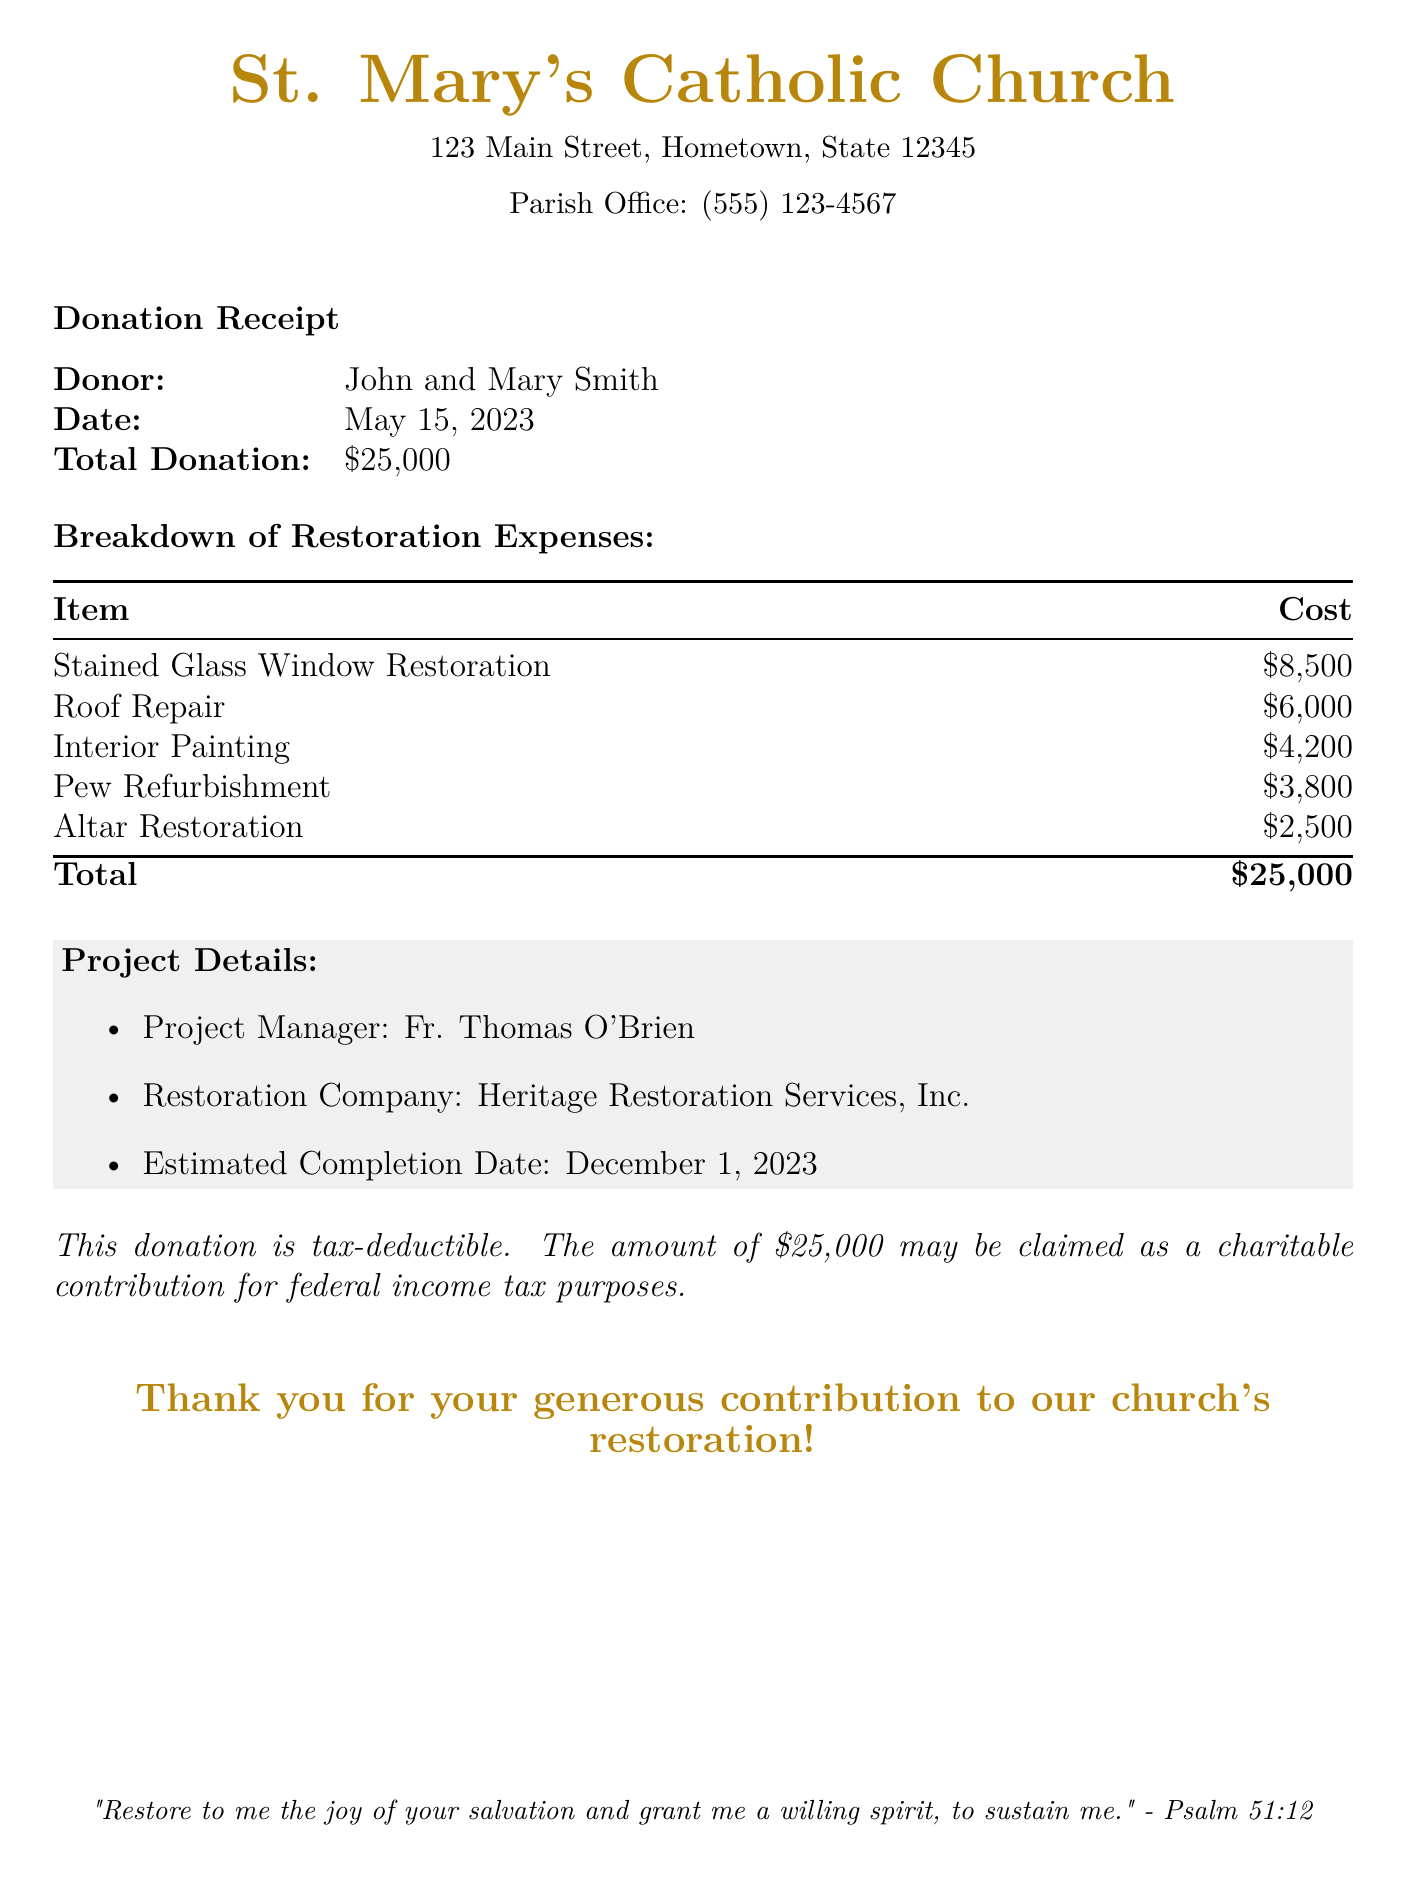what is the name of the church? The name of the church is provided at the top of the document.
Answer: St. Mary's Catholic Church who made the donation? The donor's name is mentioned in the donation receipt section of the document.
Answer: John and Mary Smith what was the total amount of the donation? The total donation amount is specified in the receipt.
Answer: $25,000 how much was allocated for stained glass window restoration? The cost for stained glass window restoration is listed in the breakdown of restoration expenses.
Answer: $8,500 who is the project manager? The project manager's name is included in the project details section of the document.
Answer: Fr. Thomas O'Brien what is the estimated completion date of the restoration project? The estimated completion date is specified in the project details section.
Answer: December 1, 2023 how much did the pew refurbishment cost? The cost of pew refurbishment is stated in the breakdown of restoration expenses.
Answer: $3,800 what company is handling the restoration? The restoration company is mentioned in the project details section of the document.
Answer: Heritage Restoration Services, Inc how much was spent on roof repair? The amount spent on roof repair is included in the expense breakdown.
Answer: $6,000 